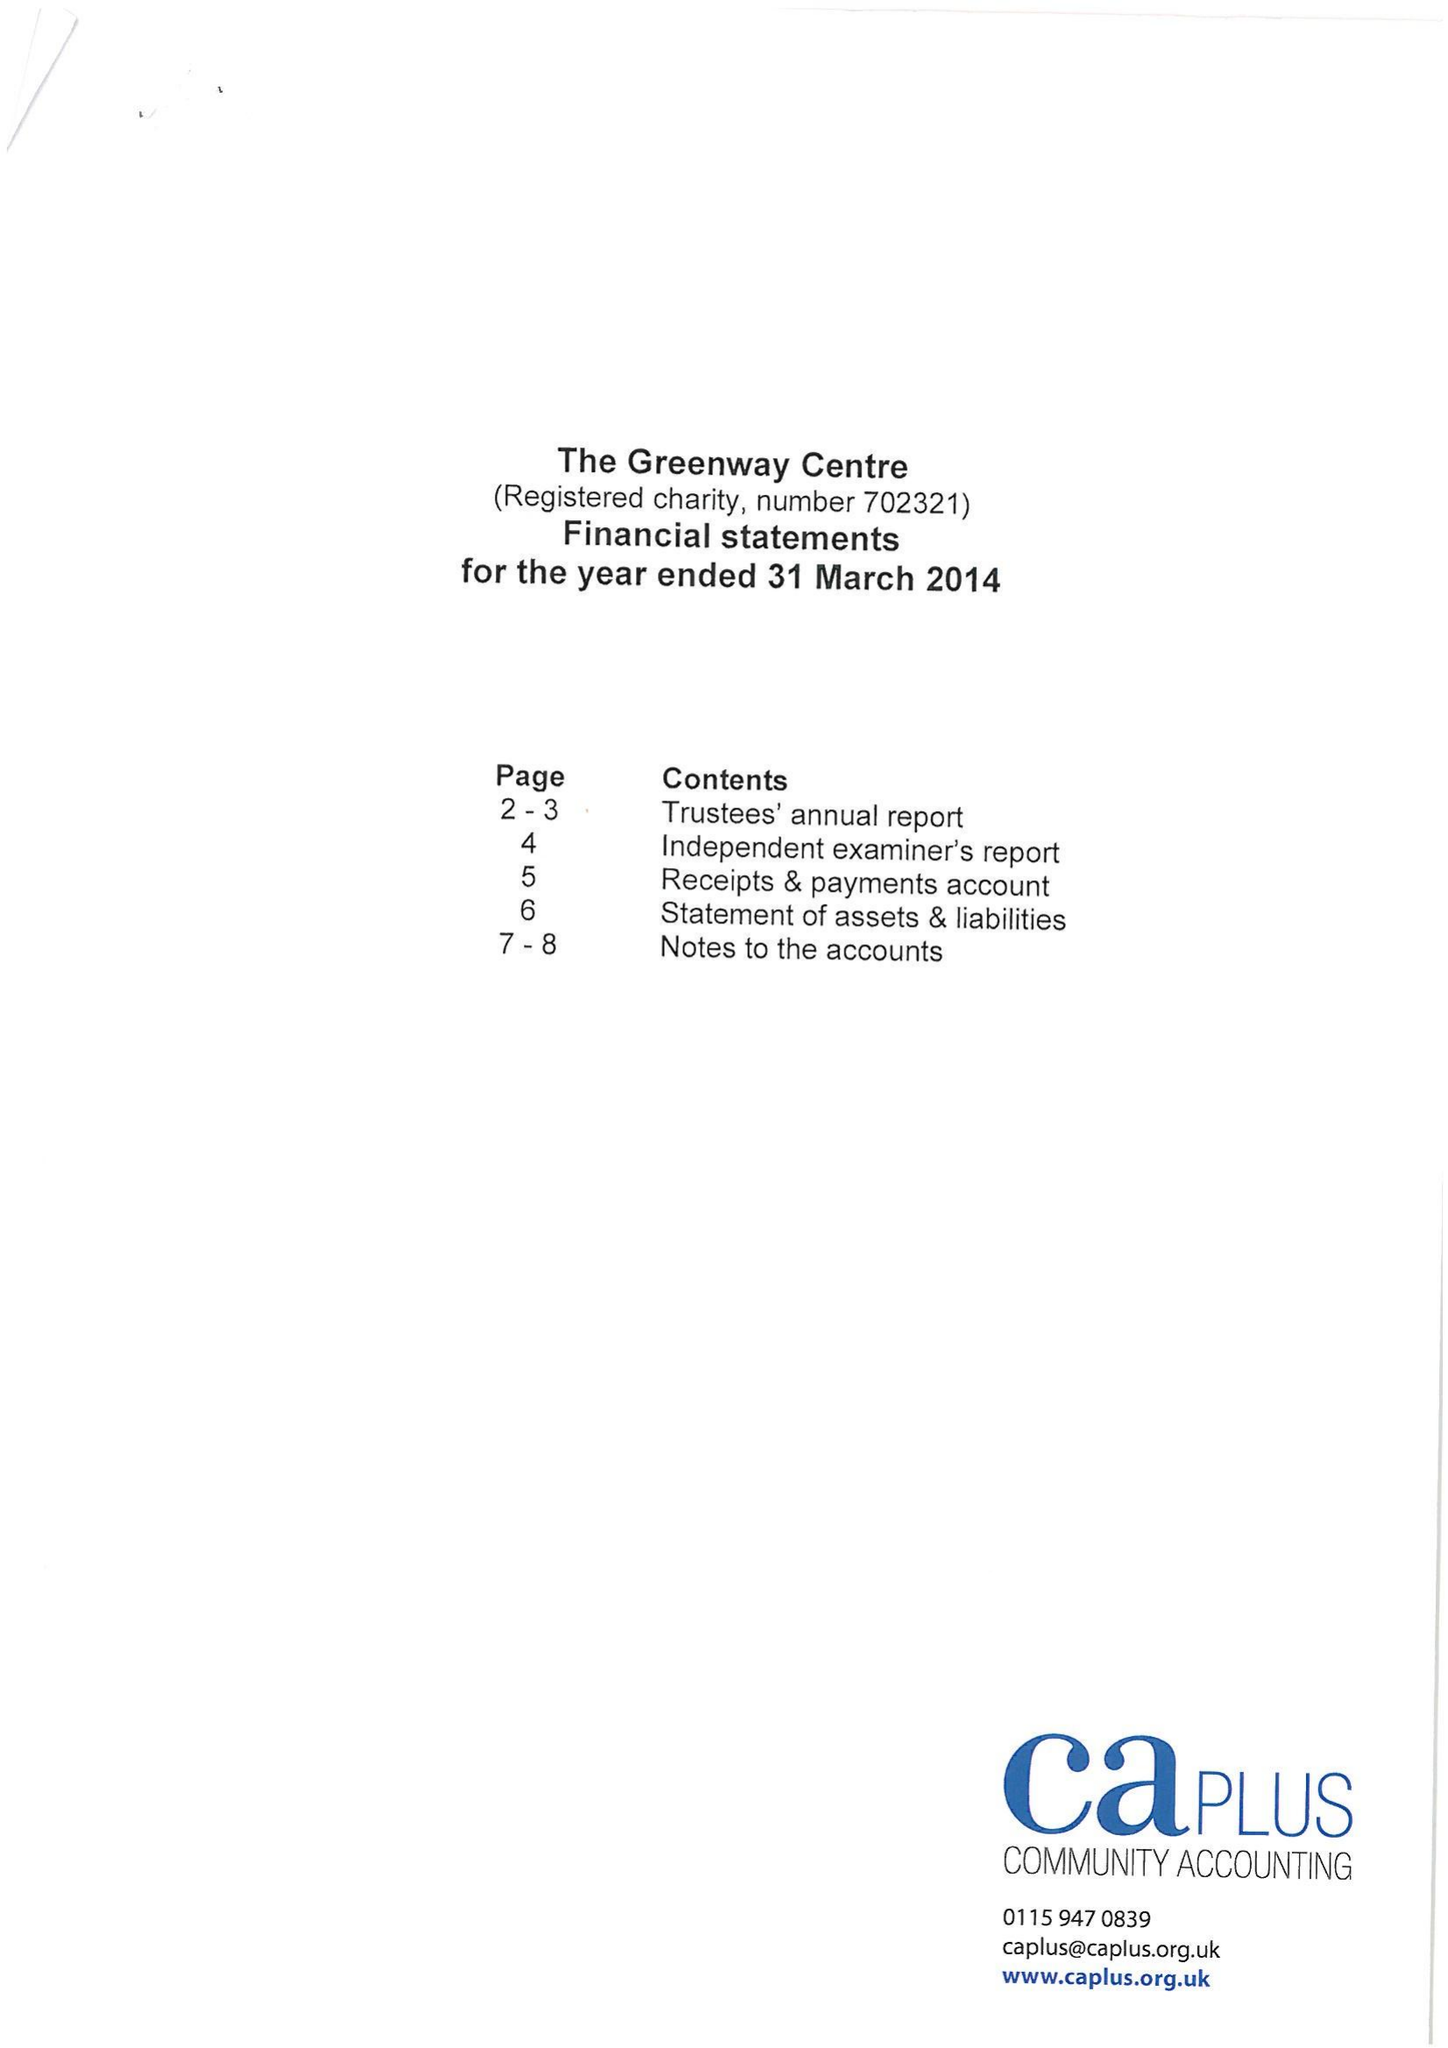What is the value for the report_date?
Answer the question using a single word or phrase. 2014-03-31 